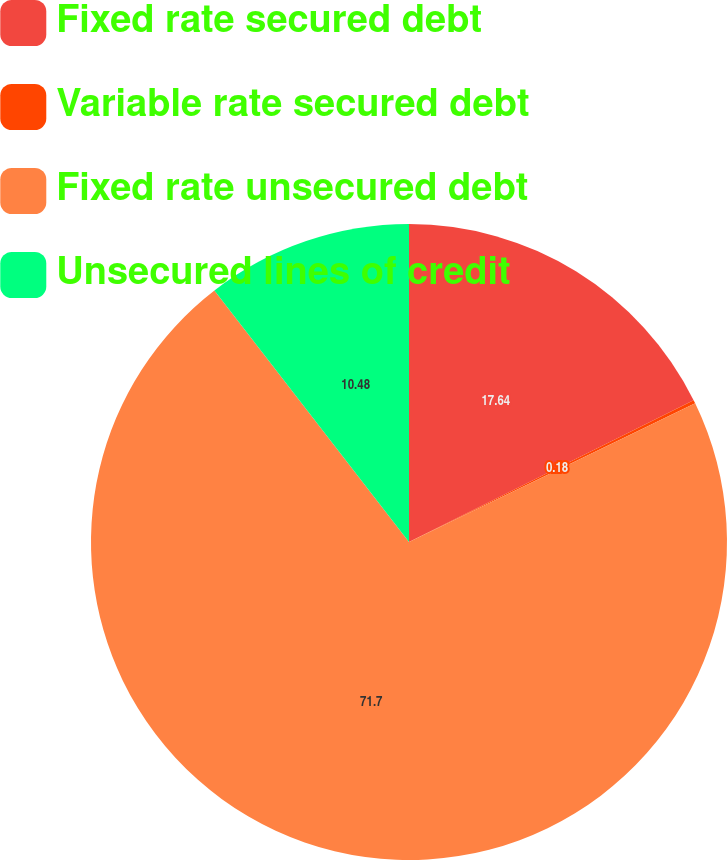<chart> <loc_0><loc_0><loc_500><loc_500><pie_chart><fcel>Fixed rate secured debt<fcel>Variable rate secured debt<fcel>Fixed rate unsecured debt<fcel>Unsecured lines of credit<nl><fcel>17.64%<fcel>0.18%<fcel>71.7%<fcel>10.48%<nl></chart> 